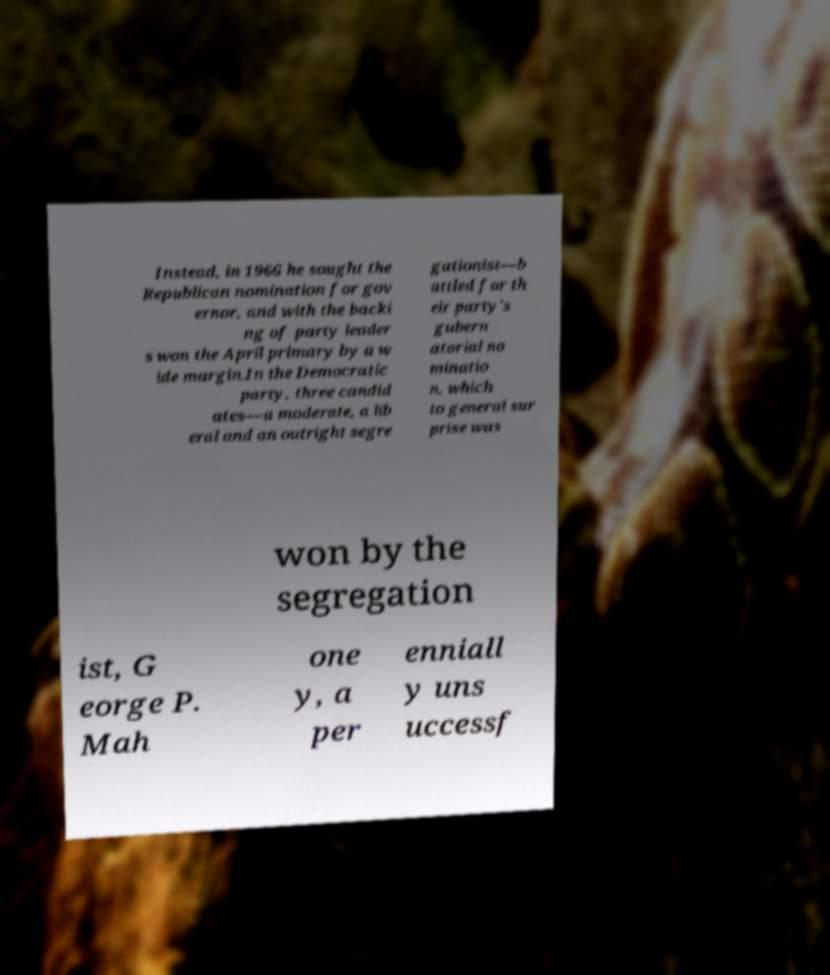For documentation purposes, I need the text within this image transcribed. Could you provide that? Instead, in 1966 he sought the Republican nomination for gov ernor, and with the backi ng of party leader s won the April primary by a w ide margin.In the Democratic party, three candid ates—a moderate, a lib eral and an outright segre gationist—b attled for th eir party's gubern atorial no minatio n, which to general sur prise was won by the segregation ist, G eorge P. Mah one y, a per enniall y uns uccessf 